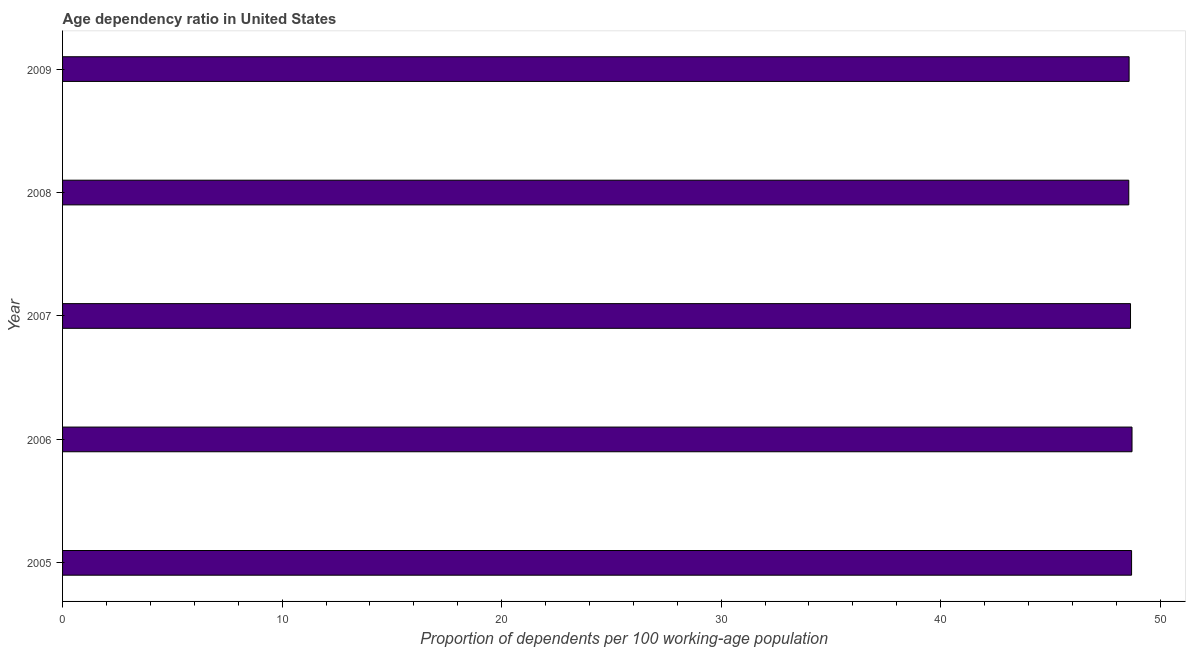What is the title of the graph?
Keep it short and to the point. Age dependency ratio in United States. What is the label or title of the X-axis?
Provide a succinct answer. Proportion of dependents per 100 working-age population. What is the age dependency ratio in 2009?
Provide a succinct answer. 48.58. Across all years, what is the maximum age dependency ratio?
Provide a succinct answer. 48.72. Across all years, what is the minimum age dependency ratio?
Your response must be concise. 48.57. In which year was the age dependency ratio maximum?
Your answer should be very brief. 2006. What is the sum of the age dependency ratio?
Ensure brevity in your answer.  243.22. What is the difference between the age dependency ratio in 2005 and 2006?
Keep it short and to the point. -0.02. What is the average age dependency ratio per year?
Give a very brief answer. 48.64. What is the median age dependency ratio?
Your response must be concise. 48.65. Is the age dependency ratio in 2007 less than that in 2009?
Make the answer very short. No. Is the difference between the age dependency ratio in 2005 and 2009 greater than the difference between any two years?
Provide a succinct answer. No. Is the sum of the age dependency ratio in 2006 and 2008 greater than the maximum age dependency ratio across all years?
Your answer should be compact. Yes. What is the difference between the highest and the lowest age dependency ratio?
Keep it short and to the point. 0.15. In how many years, is the age dependency ratio greater than the average age dependency ratio taken over all years?
Make the answer very short. 3. Are all the bars in the graph horizontal?
Your answer should be very brief. Yes. What is the Proportion of dependents per 100 working-age population of 2005?
Give a very brief answer. 48.7. What is the Proportion of dependents per 100 working-age population in 2006?
Provide a short and direct response. 48.72. What is the Proportion of dependents per 100 working-age population in 2007?
Offer a terse response. 48.65. What is the Proportion of dependents per 100 working-age population of 2008?
Keep it short and to the point. 48.57. What is the Proportion of dependents per 100 working-age population in 2009?
Your answer should be very brief. 48.58. What is the difference between the Proportion of dependents per 100 working-age population in 2005 and 2006?
Offer a very short reply. -0.02. What is the difference between the Proportion of dependents per 100 working-age population in 2005 and 2007?
Ensure brevity in your answer.  0.05. What is the difference between the Proportion of dependents per 100 working-age population in 2005 and 2008?
Keep it short and to the point. 0.13. What is the difference between the Proportion of dependents per 100 working-age population in 2005 and 2009?
Make the answer very short. 0.11. What is the difference between the Proportion of dependents per 100 working-age population in 2006 and 2007?
Make the answer very short. 0.07. What is the difference between the Proportion of dependents per 100 working-age population in 2006 and 2008?
Offer a very short reply. 0.15. What is the difference between the Proportion of dependents per 100 working-age population in 2006 and 2009?
Your answer should be compact. 0.13. What is the difference between the Proportion of dependents per 100 working-age population in 2007 and 2008?
Offer a terse response. 0.08. What is the difference between the Proportion of dependents per 100 working-age population in 2007 and 2009?
Make the answer very short. 0.06. What is the difference between the Proportion of dependents per 100 working-age population in 2008 and 2009?
Your response must be concise. -0.01. What is the ratio of the Proportion of dependents per 100 working-age population in 2005 to that in 2006?
Make the answer very short. 1. What is the ratio of the Proportion of dependents per 100 working-age population in 2005 to that in 2007?
Keep it short and to the point. 1. What is the ratio of the Proportion of dependents per 100 working-age population in 2006 to that in 2008?
Provide a succinct answer. 1. What is the ratio of the Proportion of dependents per 100 working-age population in 2006 to that in 2009?
Your response must be concise. 1. What is the ratio of the Proportion of dependents per 100 working-age population in 2007 to that in 2009?
Your answer should be compact. 1. What is the ratio of the Proportion of dependents per 100 working-age population in 2008 to that in 2009?
Your answer should be very brief. 1. 